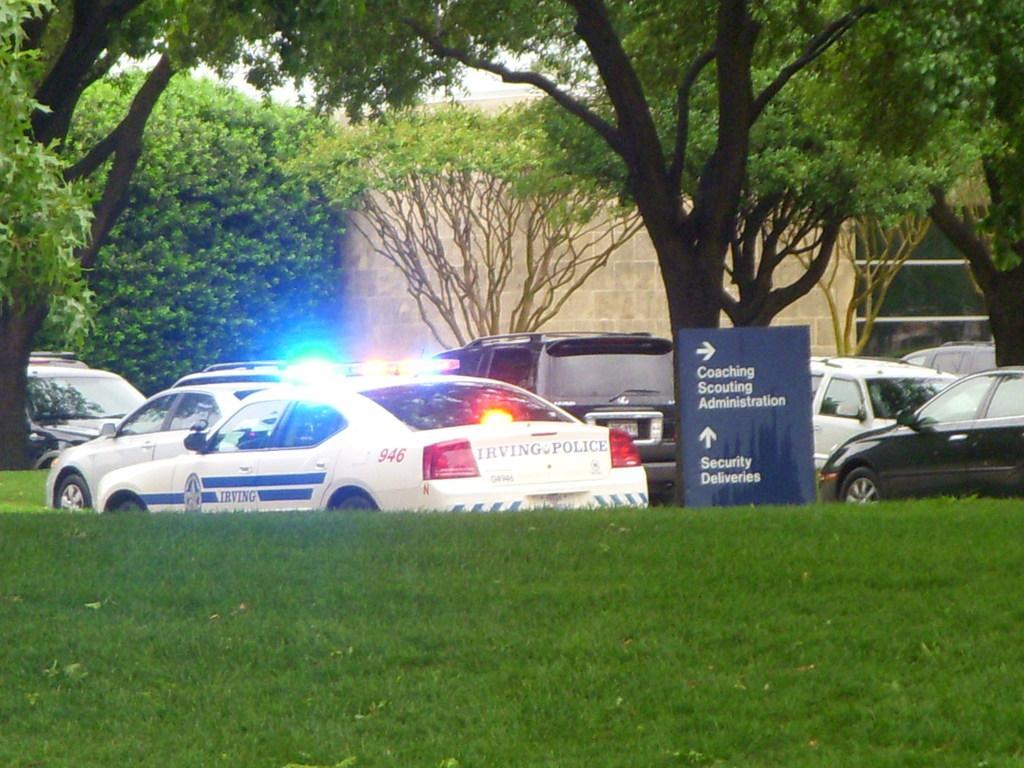In one or two sentences, can you explain what this image depicts? At the bottom of the image there is grass. In the center of the image there are cars. In the background of the image there are trees and wall. 